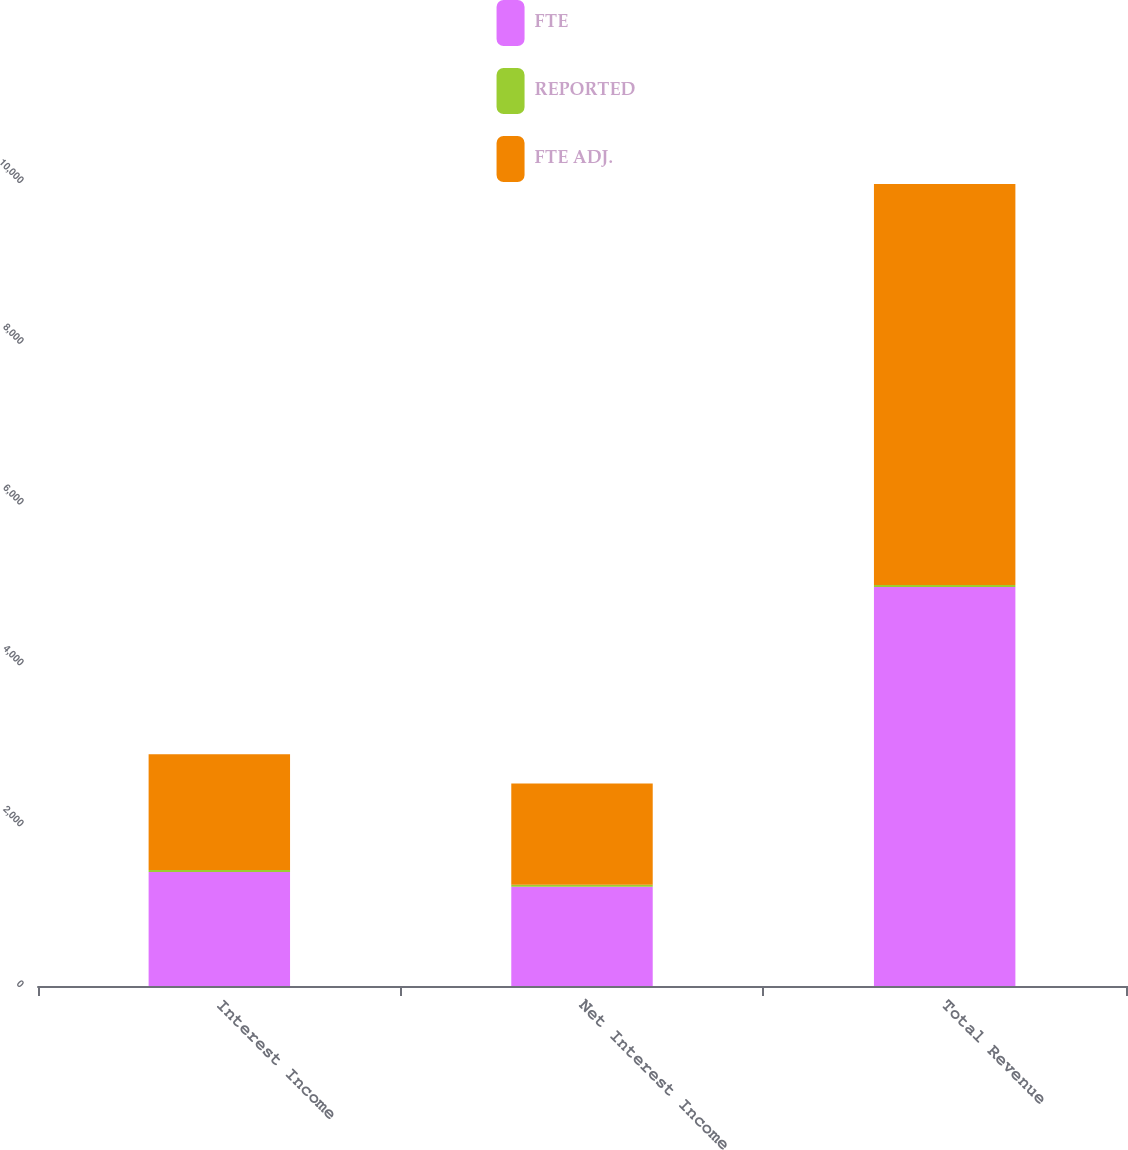<chart> <loc_0><loc_0><loc_500><loc_500><stacked_bar_chart><ecel><fcel>Interest Income<fcel>Net Interest Income<fcel>Total Revenue<nl><fcel>FTE<fcel>1416.9<fcel>1234.9<fcel>4961.8<nl><fcel>REPORTED<fcel>25.1<fcel>25.1<fcel>25.1<nl><fcel>FTE ADJ.<fcel>1442<fcel>1260<fcel>4986.9<nl></chart> 